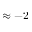Convert formula to latex. <formula><loc_0><loc_0><loc_500><loc_500>\approx - 2</formula> 